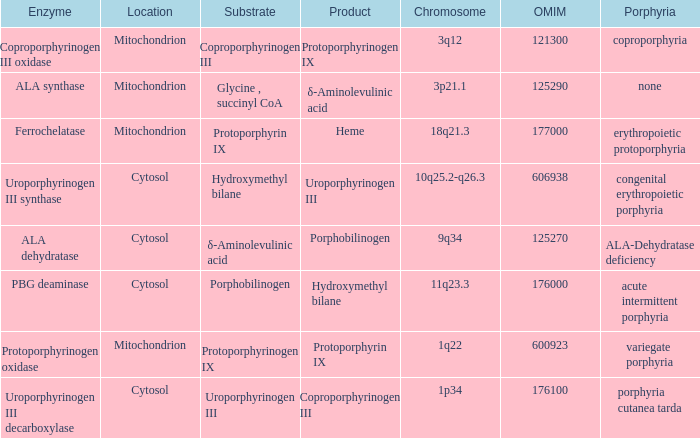What is protoporphyrin ix's substrate? Protoporphyrinogen IX. 